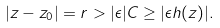Convert formula to latex. <formula><loc_0><loc_0><loc_500><loc_500>| z - z _ { 0 } | = r > | \epsilon | C \geq | \epsilon h ( z ) | .</formula> 